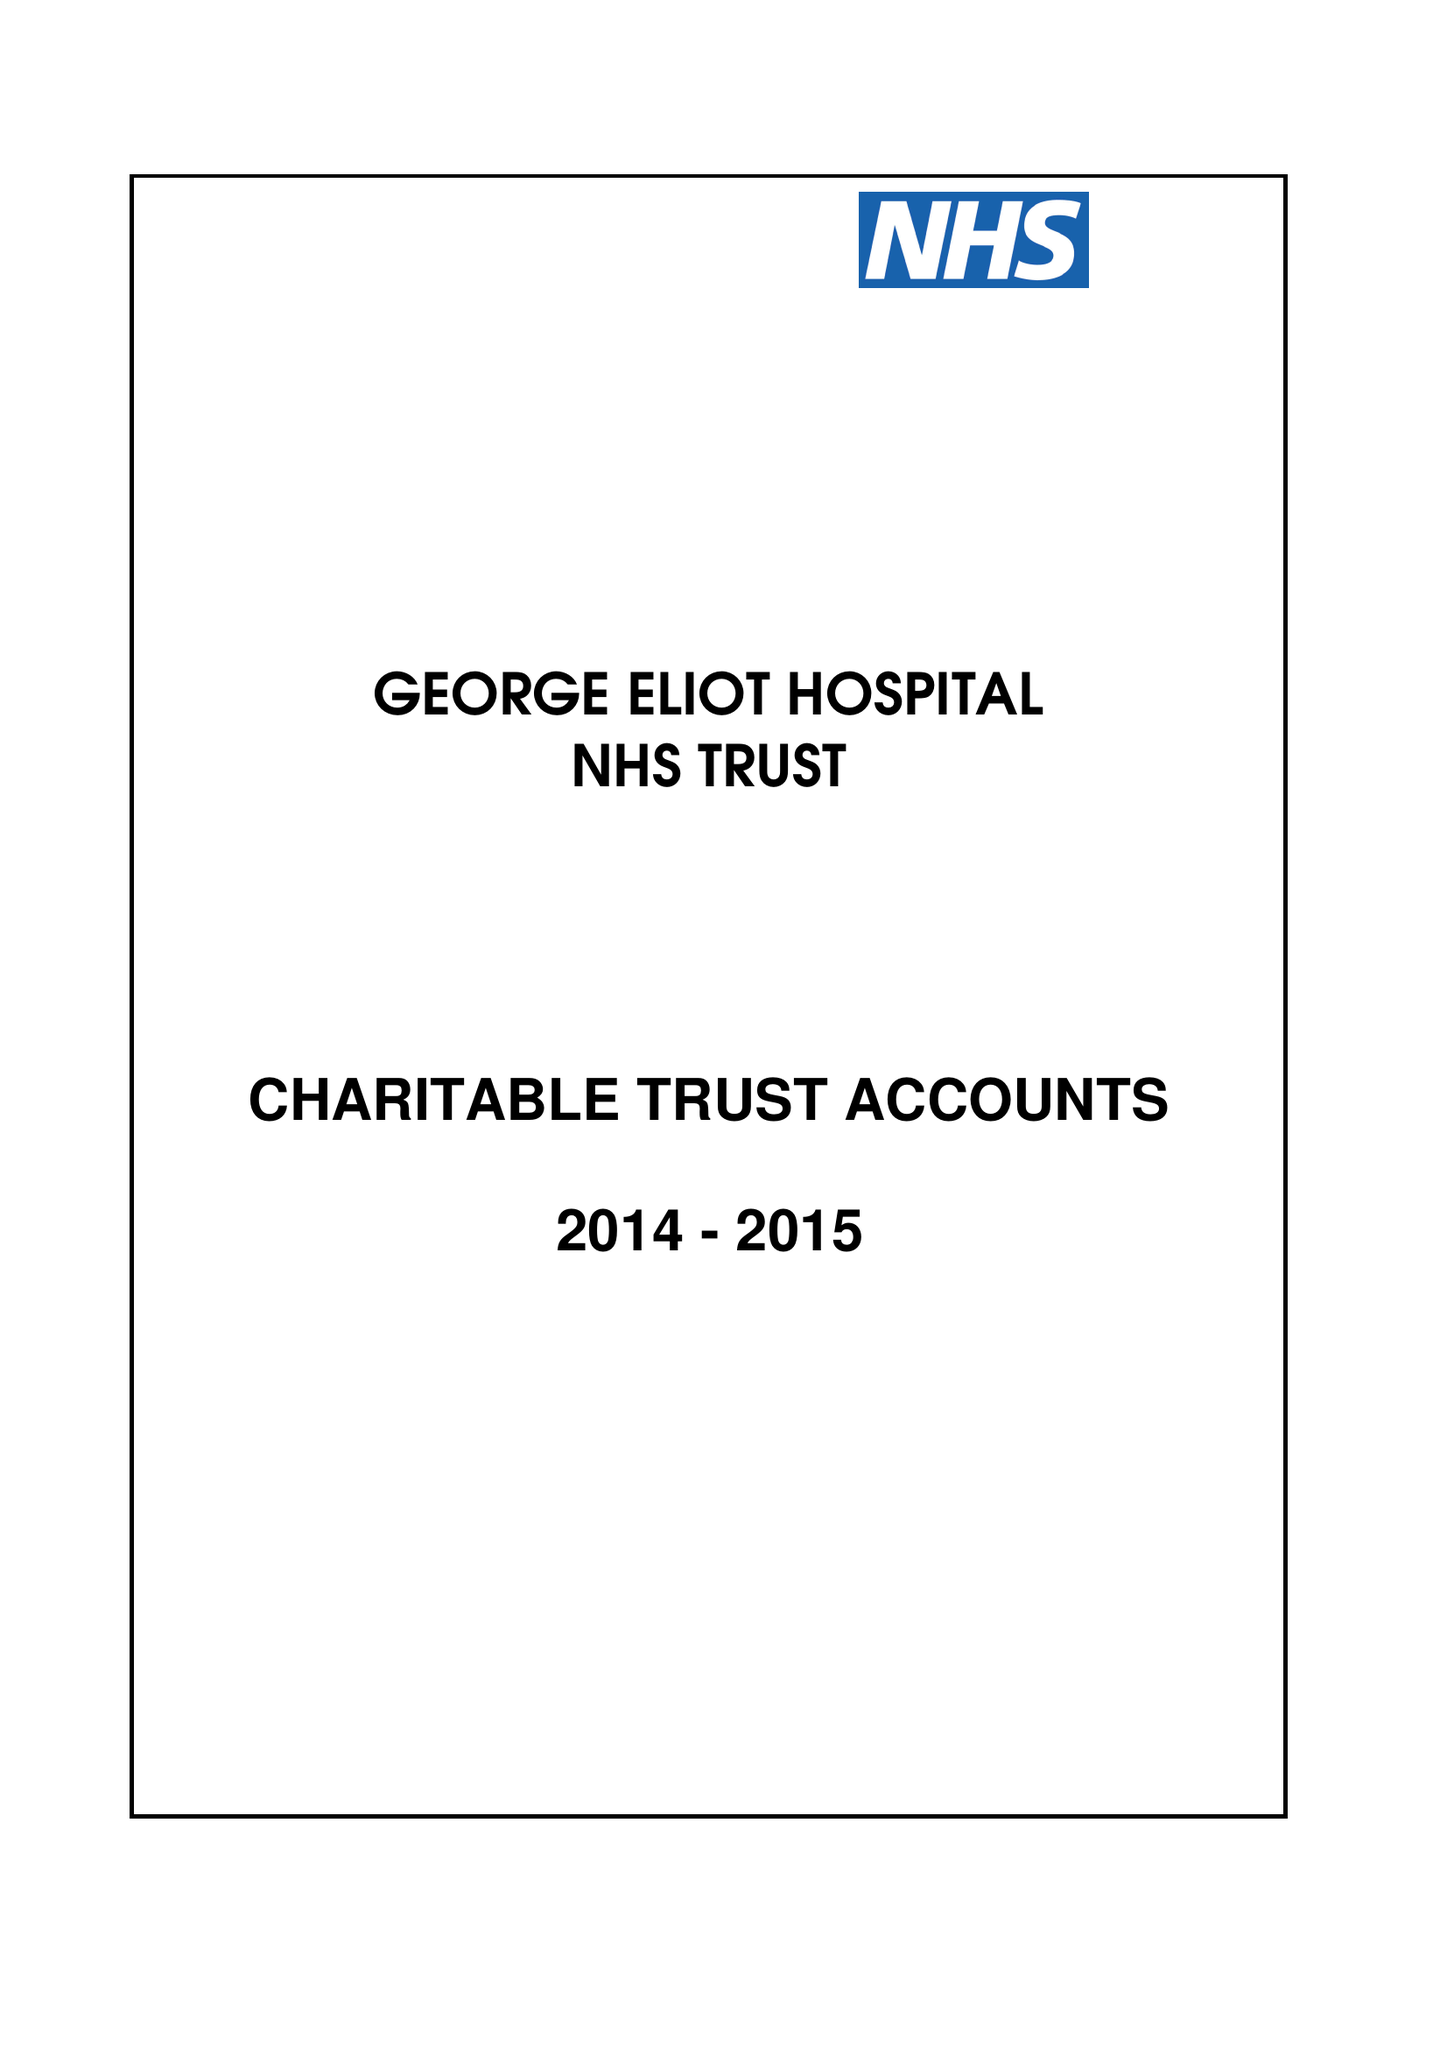What is the value for the address__postcode?
Answer the question using a single word or phrase. CV10 7DJ 